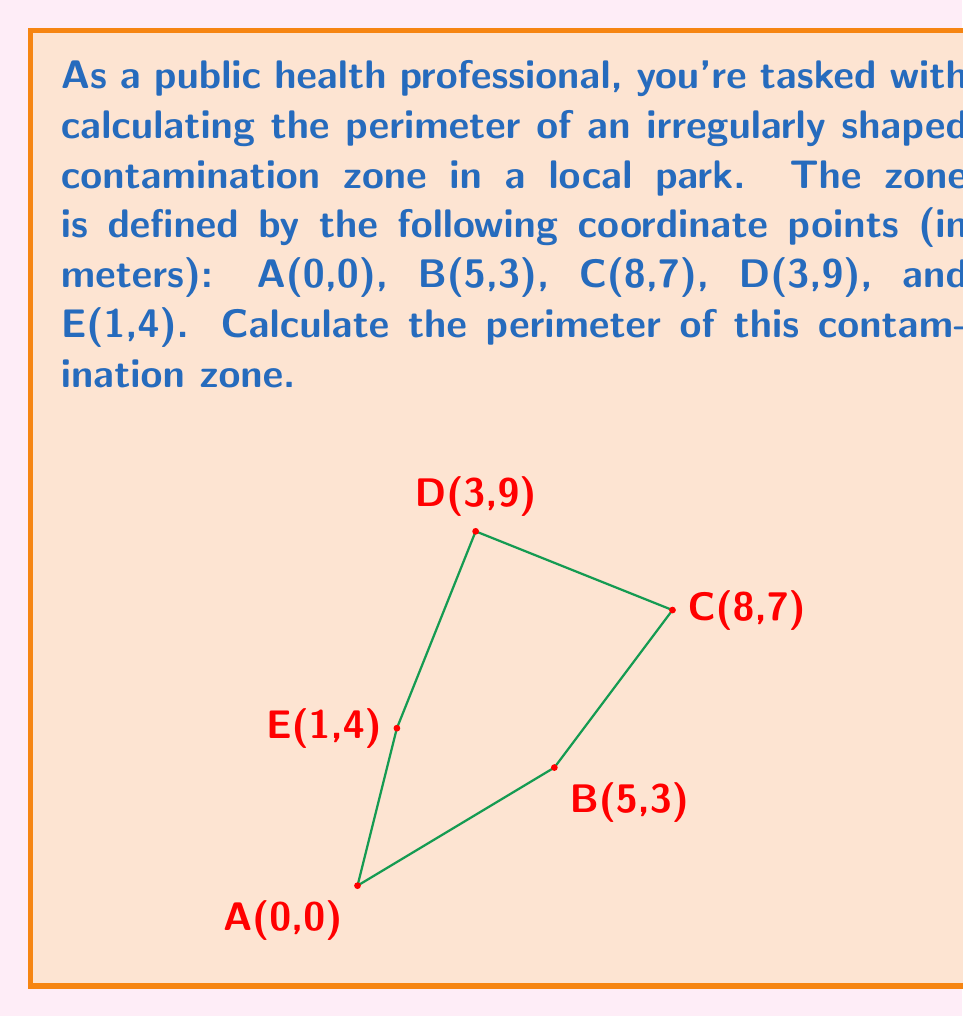Provide a solution to this math problem. To calculate the perimeter, we need to sum the distances between consecutive points, including the distance from the last point back to the first.

1) Distance AB:
   $$d_{AB} = \sqrt{(x_B - x_A)^2 + (y_B - y_A)^2} = \sqrt{(5-0)^2 + (3-0)^2} = \sqrt{34}$$

2) Distance BC:
   $$d_{BC} = \sqrt{(x_C - x_B)^2 + (y_C - y_B)^2} = \sqrt{(8-5)^2 + (7-3)^2} = \sqrt{25} = 5$$

3) Distance CD:
   $$d_{CD} = \sqrt{(x_D - x_C)^2 + (y_D - y_C)^2} = \sqrt{(3-8)^2 + (9-7)^2} = \sqrt{29}$$

4) Distance DE:
   $$d_{DE} = \sqrt{(x_E - x_D)^2 + (y_E - y_D)^2} = \sqrt{(1-3)^2 + (4-9)^2} = \sqrt{29}$$

5) Distance EA:
   $$d_{EA} = \sqrt{(x_A - x_E)^2 + (y_A - y_E)^2} = \sqrt{(0-1)^2 + (0-4)^2} = \sqrt{17}$$

6) Sum all distances to get the perimeter:
   $$\text{Perimeter} = \sqrt{34} + 5 + \sqrt{29} + \sqrt{29} + \sqrt{17}$$

7) Simplify:
   $$\text{Perimeter} = 5 + \sqrt{34} + 2\sqrt{29} + \sqrt{17}$$
Answer: $5 + \sqrt{34} + 2\sqrt{29} + \sqrt{17}$ meters 